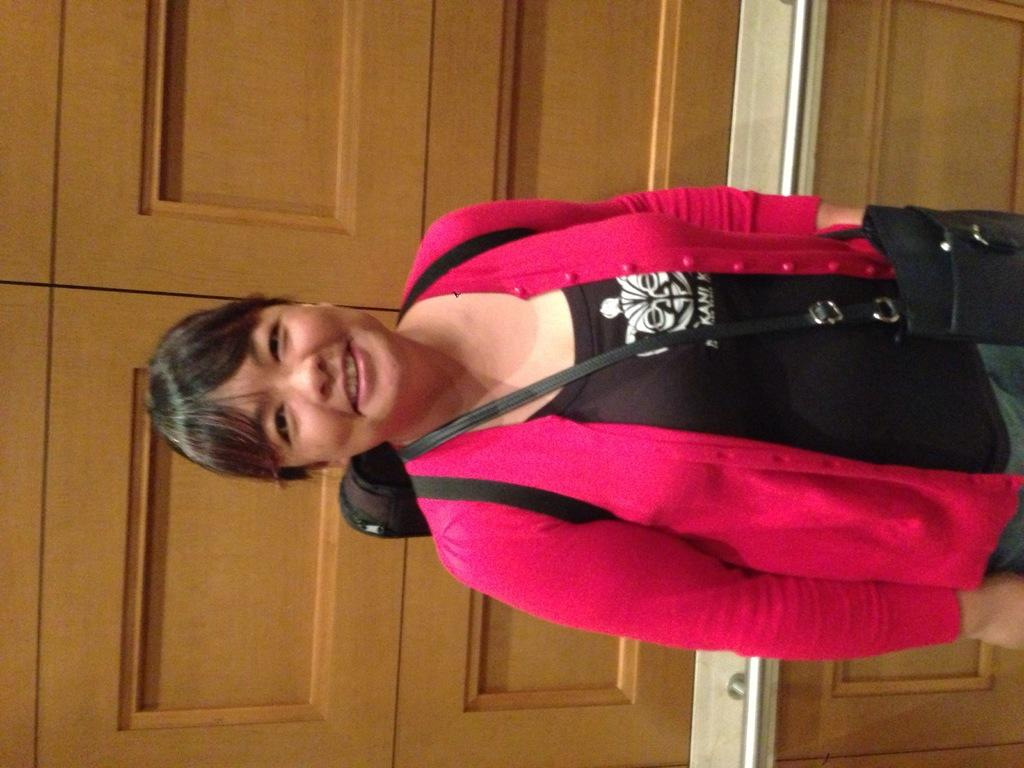Who is the main subject in the image? There is a woman in the image. Where is the woman positioned in the image? The woman is standing in the middle of the image. What is the woman wearing in the image? The woman is wearing a black top and a pink sweater. What is the woman's facial expression in the image? The woman is smiling in the image. What can be seen behind the woman in the image? There are doors visible behind the woman. What type of experience does the woman have with writing poetry in the image? There is no indication in the image that the woman has any experience with writing poetry. Can you tell me how many kittens are sitting on the woman's lap in the image? There are no kittens present in the image. 